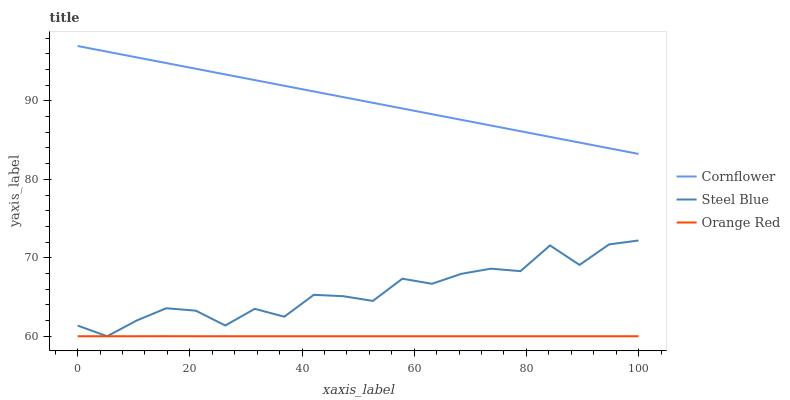Does Orange Red have the minimum area under the curve?
Answer yes or no. Yes. Does Cornflower have the maximum area under the curve?
Answer yes or no. Yes. Does Steel Blue have the minimum area under the curve?
Answer yes or no. No. Does Steel Blue have the maximum area under the curve?
Answer yes or no. No. Is Cornflower the smoothest?
Answer yes or no. Yes. Is Steel Blue the roughest?
Answer yes or no. Yes. Is Orange Red the smoothest?
Answer yes or no. No. Is Orange Red the roughest?
Answer yes or no. No. Does Cornflower have the highest value?
Answer yes or no. Yes. Does Steel Blue have the highest value?
Answer yes or no. No. Is Orange Red less than Cornflower?
Answer yes or no. Yes. Is Cornflower greater than Orange Red?
Answer yes or no. Yes. Does Orange Red intersect Steel Blue?
Answer yes or no. Yes. Is Orange Red less than Steel Blue?
Answer yes or no. No. Is Orange Red greater than Steel Blue?
Answer yes or no. No. Does Orange Red intersect Cornflower?
Answer yes or no. No. 